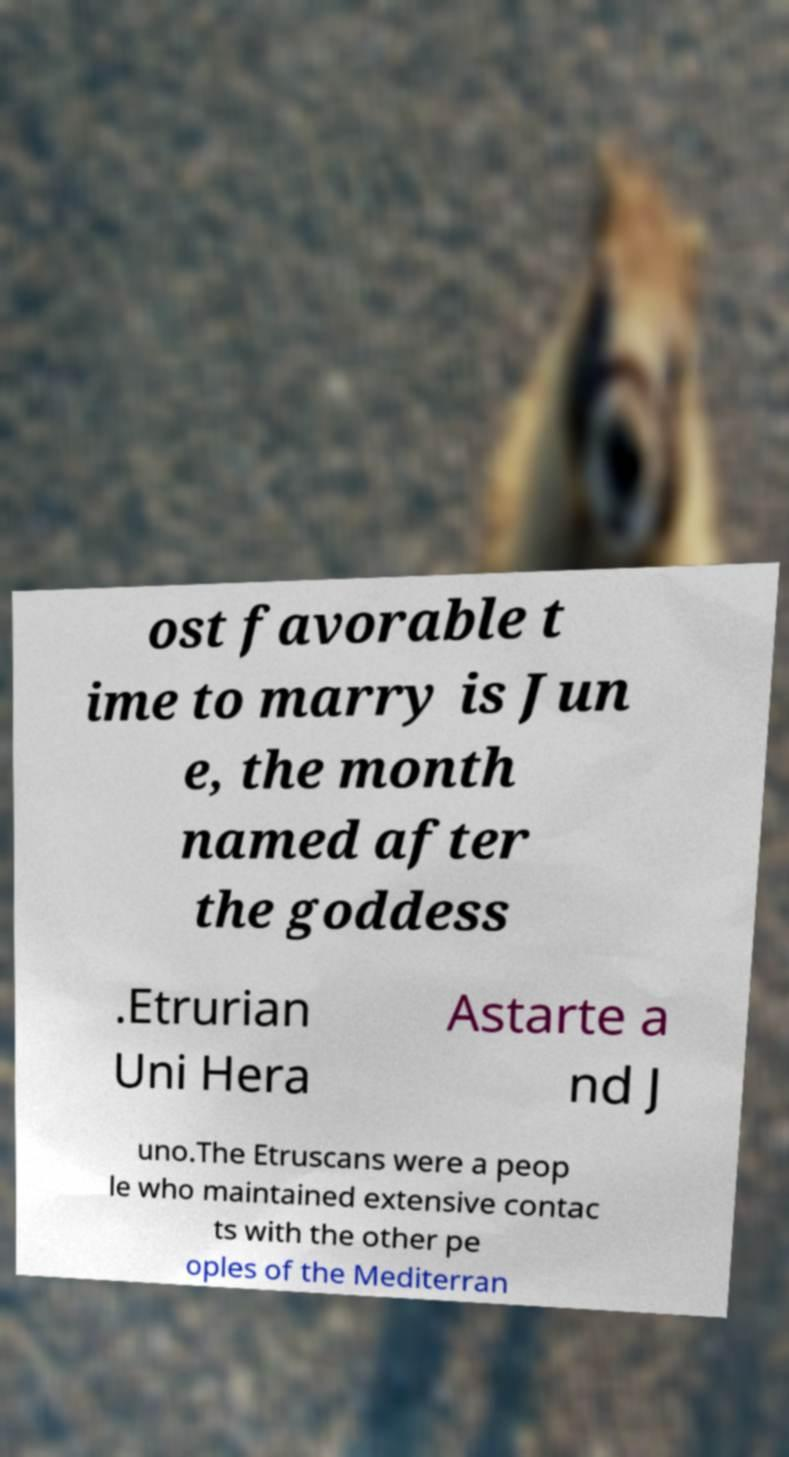Could you extract and type out the text from this image? ost favorable t ime to marry is Jun e, the month named after the goddess .Etrurian Uni Hera Astarte a nd J uno.The Etruscans were a peop le who maintained extensive contac ts with the other pe oples of the Mediterran 